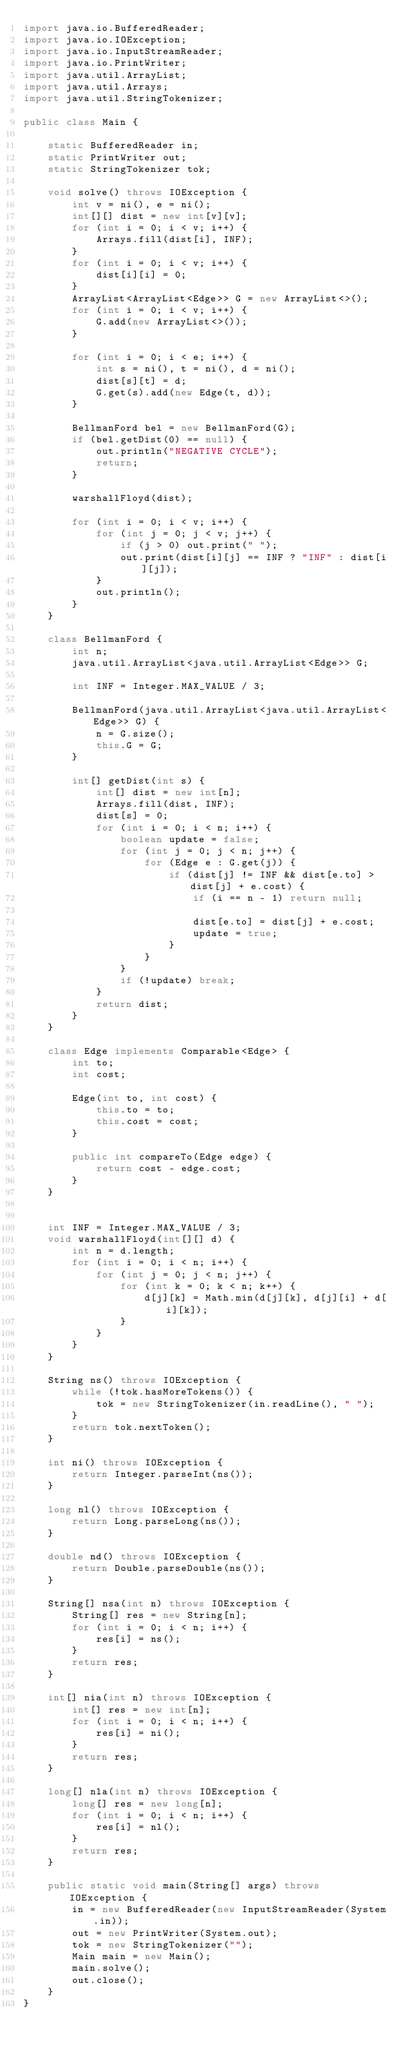Convert code to text. <code><loc_0><loc_0><loc_500><loc_500><_Java_>import java.io.BufferedReader;
import java.io.IOException;
import java.io.InputStreamReader;
import java.io.PrintWriter;
import java.util.ArrayList;
import java.util.Arrays;
import java.util.StringTokenizer;

public class Main {

    static BufferedReader in;
    static PrintWriter out;
    static StringTokenizer tok;

    void solve() throws IOException {
        int v = ni(), e = ni();
        int[][] dist = new int[v][v];
        for (int i = 0; i < v; i++) {
            Arrays.fill(dist[i], INF);
        }
        for (int i = 0; i < v; i++) {
            dist[i][i] = 0;
        }
        ArrayList<ArrayList<Edge>> G = new ArrayList<>();
        for (int i = 0; i < v; i++) {
            G.add(new ArrayList<>());
        }

        for (int i = 0; i < e; i++) {
            int s = ni(), t = ni(), d = ni();
            dist[s][t] = d;
            G.get(s).add(new Edge(t, d));
        }

        BellmanFord bel = new BellmanFord(G);
        if (bel.getDist(0) == null) {
            out.println("NEGATIVE CYCLE");
            return;
        }

        warshallFloyd(dist);

        for (int i = 0; i < v; i++) {
            for (int j = 0; j < v; j++) {
                if (j > 0) out.print(" ");
                out.print(dist[i][j] == INF ? "INF" : dist[i][j]);
            }
            out.println();
        }
    }

    class BellmanFord {
        int n;
        java.util.ArrayList<java.util.ArrayList<Edge>> G;

        int INF = Integer.MAX_VALUE / 3;

        BellmanFord(java.util.ArrayList<java.util.ArrayList<Edge>> G) {
            n = G.size();
            this.G = G;
        }

        int[] getDist(int s) {
            int[] dist = new int[n];
            Arrays.fill(dist, INF);
            dist[s] = 0;
            for (int i = 0; i < n; i++) {
                boolean update = false;
                for (int j = 0; j < n; j++) {
                    for (Edge e : G.get(j)) {
                        if (dist[j] != INF && dist[e.to] > dist[j] + e.cost) {
                            if (i == n - 1) return null;

                            dist[e.to] = dist[j] + e.cost;
                            update = true;
                        }
                    }
                }
                if (!update) break;
            }
            return dist;
        }
    }

    class Edge implements Comparable<Edge> {
        int to;
        int cost;

        Edge(int to, int cost) {
            this.to = to;
            this.cost = cost;
        }

        public int compareTo(Edge edge) {
            return cost - edge.cost;
        }
    }


    int INF = Integer.MAX_VALUE / 3;
    void warshallFloyd(int[][] d) {
        int n = d.length;
        for (int i = 0; i < n; i++) {
            for (int j = 0; j < n; j++) {
                for (int k = 0; k < n; k++) {
                    d[j][k] = Math.min(d[j][k], d[j][i] + d[i][k]);
                }
            }
        }
    }

    String ns() throws IOException {
        while (!tok.hasMoreTokens()) {
            tok = new StringTokenizer(in.readLine(), " ");
        }
        return tok.nextToken();
    }

    int ni() throws IOException {
        return Integer.parseInt(ns());
    }

    long nl() throws IOException {
        return Long.parseLong(ns());
    }

    double nd() throws IOException {
        return Double.parseDouble(ns());
    }

    String[] nsa(int n) throws IOException {
        String[] res = new String[n];
        for (int i = 0; i < n; i++) {
            res[i] = ns();
        }
        return res;
    }

    int[] nia(int n) throws IOException {
        int[] res = new int[n];
        for (int i = 0; i < n; i++) {
            res[i] = ni();
        }
        return res;
    }

    long[] nla(int n) throws IOException {
        long[] res = new long[n];
        for (int i = 0; i < n; i++) {
            res[i] = nl();
        }
        return res;
    }

    public static void main(String[] args) throws IOException {
        in = new BufferedReader(new InputStreamReader(System.in));
        out = new PrintWriter(System.out);
        tok = new StringTokenizer("");
        Main main = new Main();
        main.solve();
        out.close();
    }
}</code> 